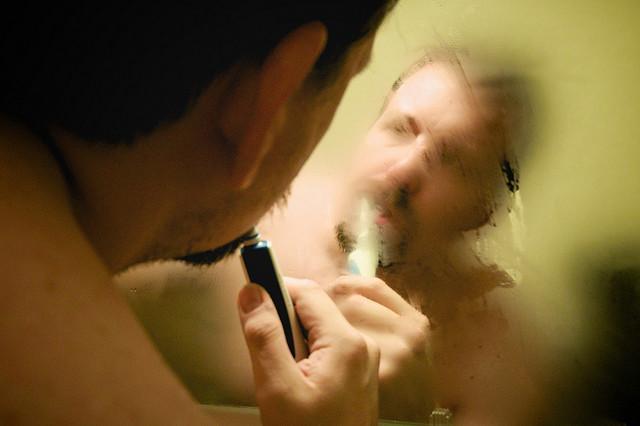How many people can you see?
Give a very brief answer. 2. How many bears do you see?
Give a very brief answer. 0. 